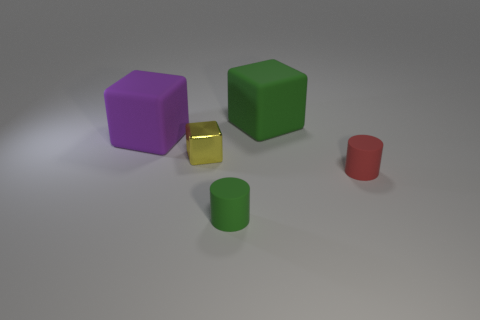There is a yellow thing; is it the same size as the green rubber thing behind the yellow metallic cube?
Your answer should be very brief. No. Is there a shiny thing of the same color as the small block?
Make the answer very short. No. Are there any small green things of the same shape as the big green matte object?
Make the answer very short. No. What shape is the thing that is behind the small yellow object and in front of the green cube?
Your response must be concise. Cube. How many large purple objects have the same material as the tiny yellow object?
Ensure brevity in your answer.  0. Are there fewer green matte things that are behind the large purple rubber cube than large yellow metal spheres?
Your response must be concise. No. Is there a yellow metallic object left of the object that is on the left side of the yellow thing?
Make the answer very short. No. Are there any other things that have the same shape as the tiny red rubber object?
Keep it short and to the point. Yes. Do the shiny block and the purple object have the same size?
Make the answer very short. No. What material is the big thing to the right of the matte block that is on the left side of the tiny cylinder left of the green block made of?
Make the answer very short. Rubber. 